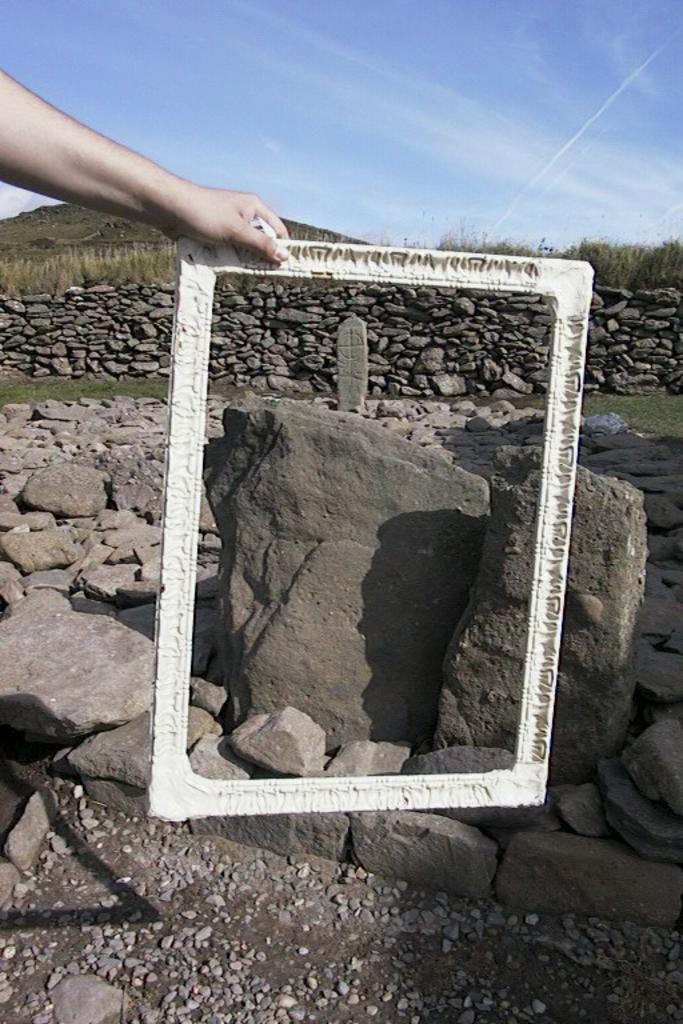What is being held in the image? There is a hand holding a frame in the image. What can be seen behind the frame? There are plenty of rocks and stones visible behind the frame. What type of argument is the aunt having with the prose in the image? There is no aunt or prose present in the image; it only features a hand holding a frame and rocks and stones in the background. 